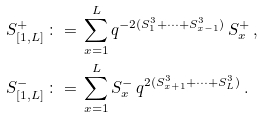<formula> <loc_0><loc_0><loc_500><loc_500>S _ { [ 1 , L ] } ^ { + } \, & \colon = \, \sum _ { x = 1 } ^ { L } q ^ { - 2 ( S _ { 1 } ^ { 3 } + \dots + S _ { x - 1 } ^ { 3 } ) } \, S _ { x } ^ { + } \, , \\ S _ { [ 1 , L ] } ^ { - } \, & \colon = \, \sum _ { x = 1 } ^ { L } S _ { x } ^ { - } \, q ^ { 2 ( S _ { x + 1 } ^ { 3 } + \dots + S _ { L } ^ { 3 } ) } \, .</formula> 